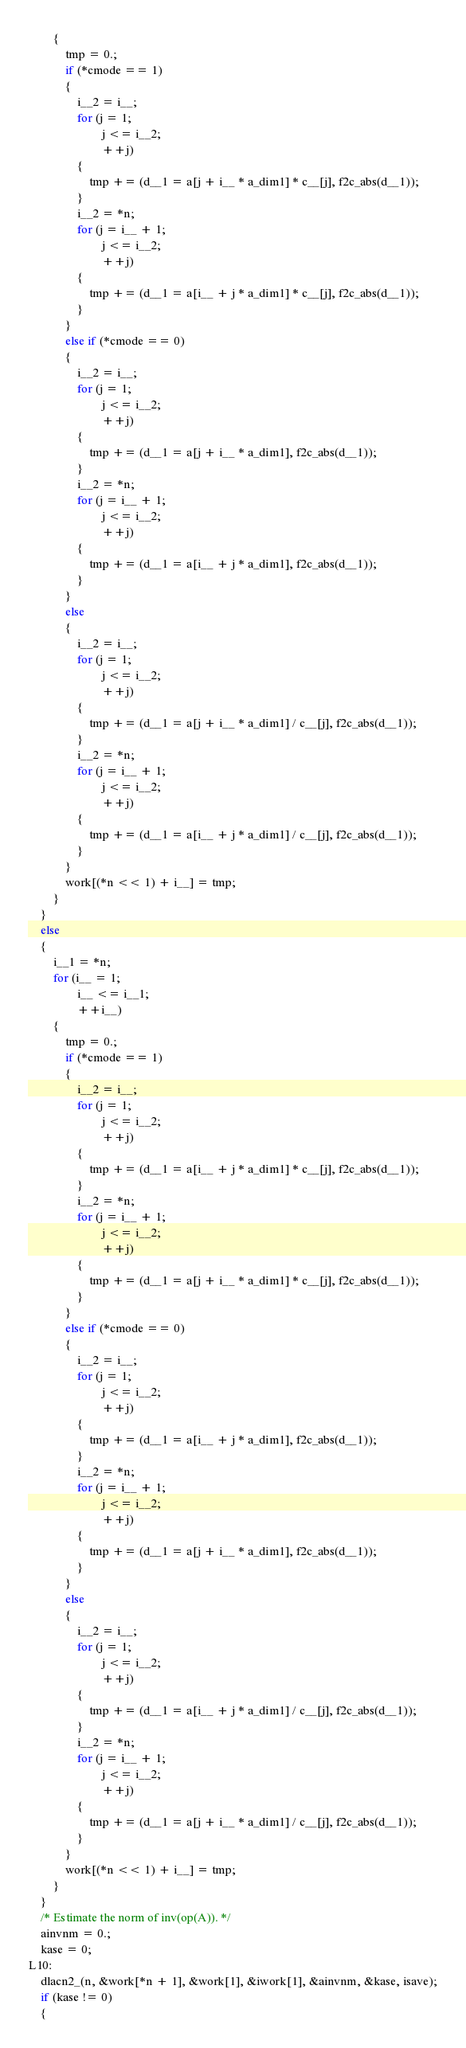<code> <loc_0><loc_0><loc_500><loc_500><_C_>        {
            tmp = 0.;
            if (*cmode == 1)
            {
                i__2 = i__;
                for (j = 1;
                        j <= i__2;
                        ++j)
                {
                    tmp += (d__1 = a[j + i__ * a_dim1] * c__[j], f2c_abs(d__1));
                }
                i__2 = *n;
                for (j = i__ + 1;
                        j <= i__2;
                        ++j)
                {
                    tmp += (d__1 = a[i__ + j * a_dim1] * c__[j], f2c_abs(d__1));
                }
            }
            else if (*cmode == 0)
            {
                i__2 = i__;
                for (j = 1;
                        j <= i__2;
                        ++j)
                {
                    tmp += (d__1 = a[j + i__ * a_dim1], f2c_abs(d__1));
                }
                i__2 = *n;
                for (j = i__ + 1;
                        j <= i__2;
                        ++j)
                {
                    tmp += (d__1 = a[i__ + j * a_dim1], f2c_abs(d__1));
                }
            }
            else
            {
                i__2 = i__;
                for (j = 1;
                        j <= i__2;
                        ++j)
                {
                    tmp += (d__1 = a[j + i__ * a_dim1] / c__[j], f2c_abs(d__1));
                }
                i__2 = *n;
                for (j = i__ + 1;
                        j <= i__2;
                        ++j)
                {
                    tmp += (d__1 = a[i__ + j * a_dim1] / c__[j], f2c_abs(d__1));
                }
            }
            work[(*n << 1) + i__] = tmp;
        }
    }
    else
    {
        i__1 = *n;
        for (i__ = 1;
                i__ <= i__1;
                ++i__)
        {
            tmp = 0.;
            if (*cmode == 1)
            {
                i__2 = i__;
                for (j = 1;
                        j <= i__2;
                        ++j)
                {
                    tmp += (d__1 = a[i__ + j * a_dim1] * c__[j], f2c_abs(d__1));
                }
                i__2 = *n;
                for (j = i__ + 1;
                        j <= i__2;
                        ++j)
                {
                    tmp += (d__1 = a[j + i__ * a_dim1] * c__[j], f2c_abs(d__1));
                }
            }
            else if (*cmode == 0)
            {
                i__2 = i__;
                for (j = 1;
                        j <= i__2;
                        ++j)
                {
                    tmp += (d__1 = a[i__ + j * a_dim1], f2c_abs(d__1));
                }
                i__2 = *n;
                for (j = i__ + 1;
                        j <= i__2;
                        ++j)
                {
                    tmp += (d__1 = a[j + i__ * a_dim1], f2c_abs(d__1));
                }
            }
            else
            {
                i__2 = i__;
                for (j = 1;
                        j <= i__2;
                        ++j)
                {
                    tmp += (d__1 = a[i__ + j * a_dim1] / c__[j], f2c_abs(d__1));
                }
                i__2 = *n;
                for (j = i__ + 1;
                        j <= i__2;
                        ++j)
                {
                    tmp += (d__1 = a[j + i__ * a_dim1] / c__[j], f2c_abs(d__1));
                }
            }
            work[(*n << 1) + i__] = tmp;
        }
    }
    /* Estimate the norm of inv(op(A)). */
    ainvnm = 0.;
    kase = 0;
L10:
    dlacn2_(n, &work[*n + 1], &work[1], &iwork[1], &ainvnm, &kase, isave);
    if (kase != 0)
    {</code> 